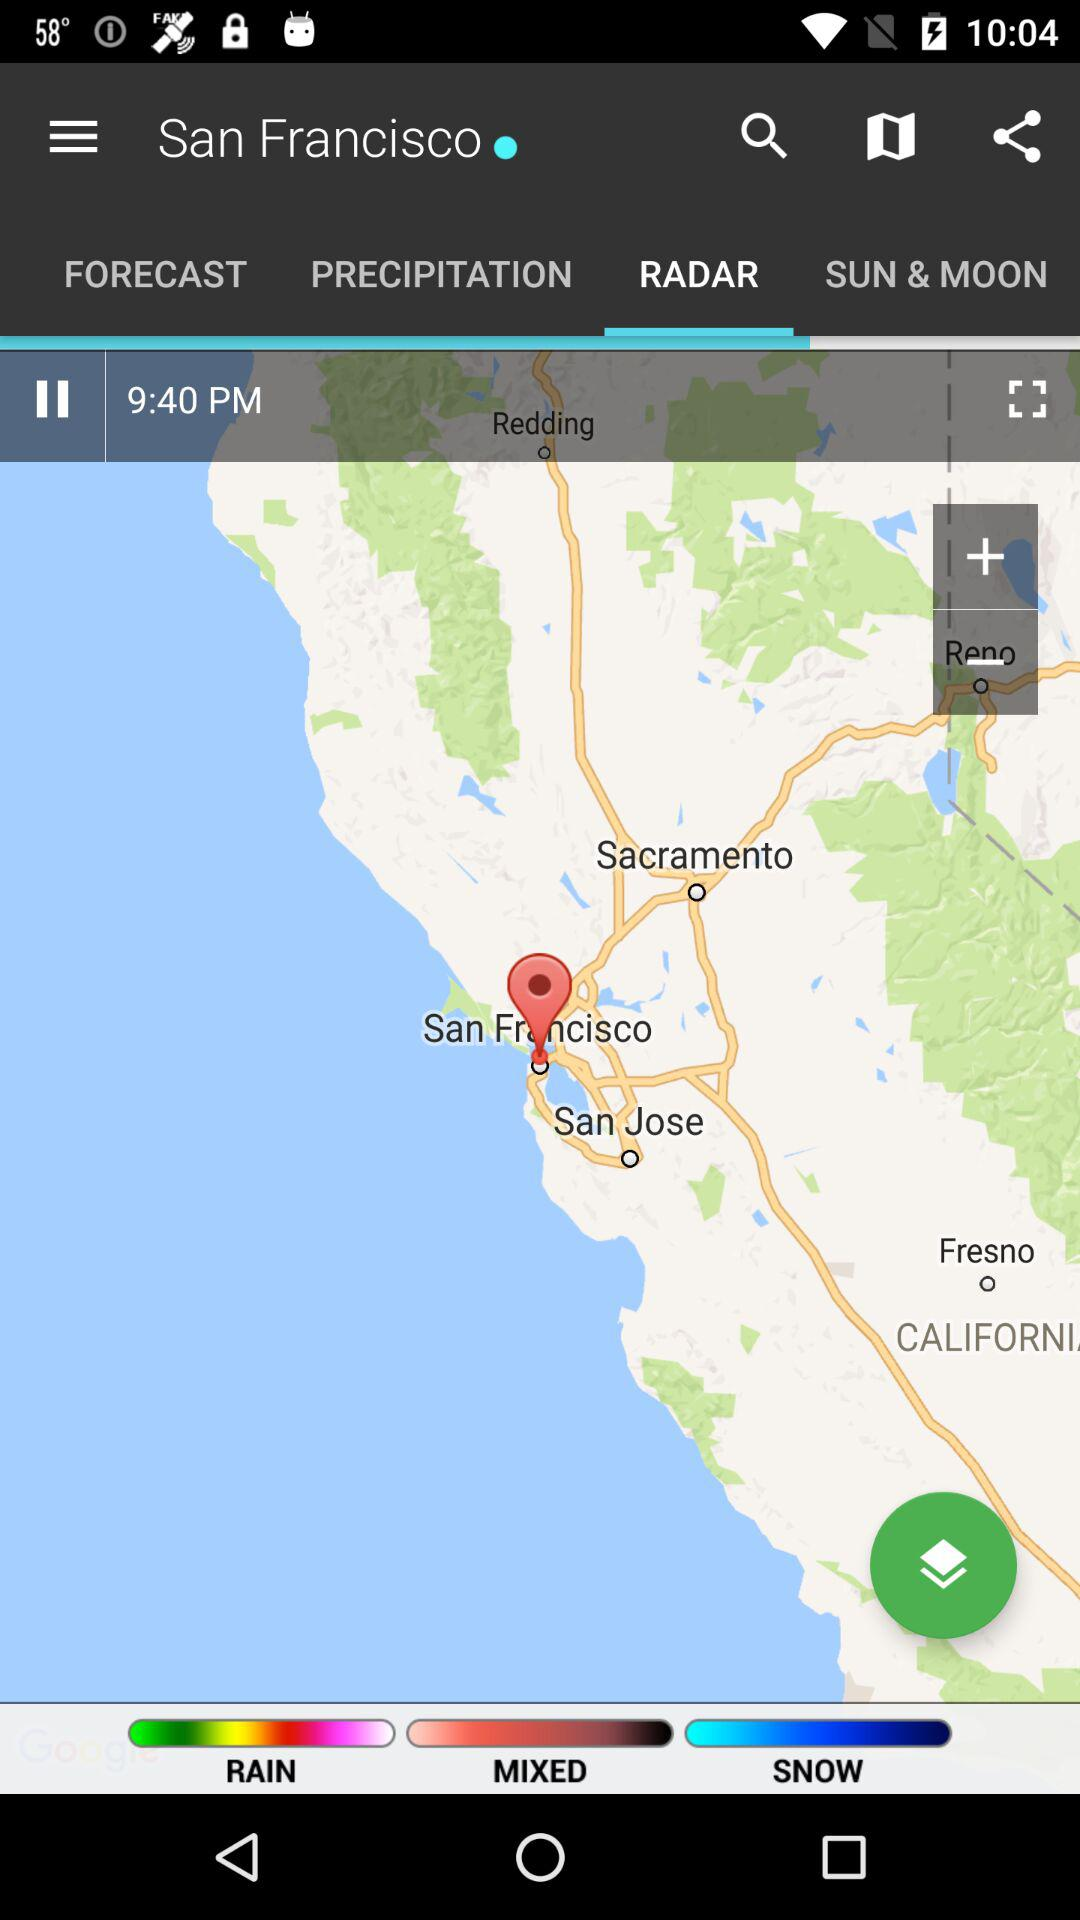What is the mentioned location in the top bar? The mentioned location in the top bar is San Francisco. 